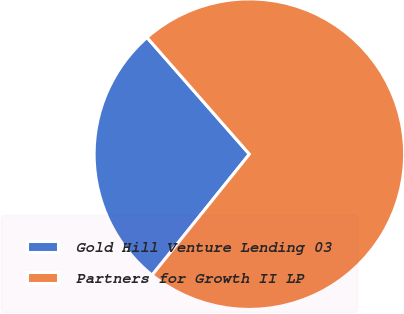Convert chart to OTSL. <chart><loc_0><loc_0><loc_500><loc_500><pie_chart><fcel>Gold Hill Venture Lending 03<fcel>Partners for Growth II LP<nl><fcel>27.76%<fcel>72.24%<nl></chart> 